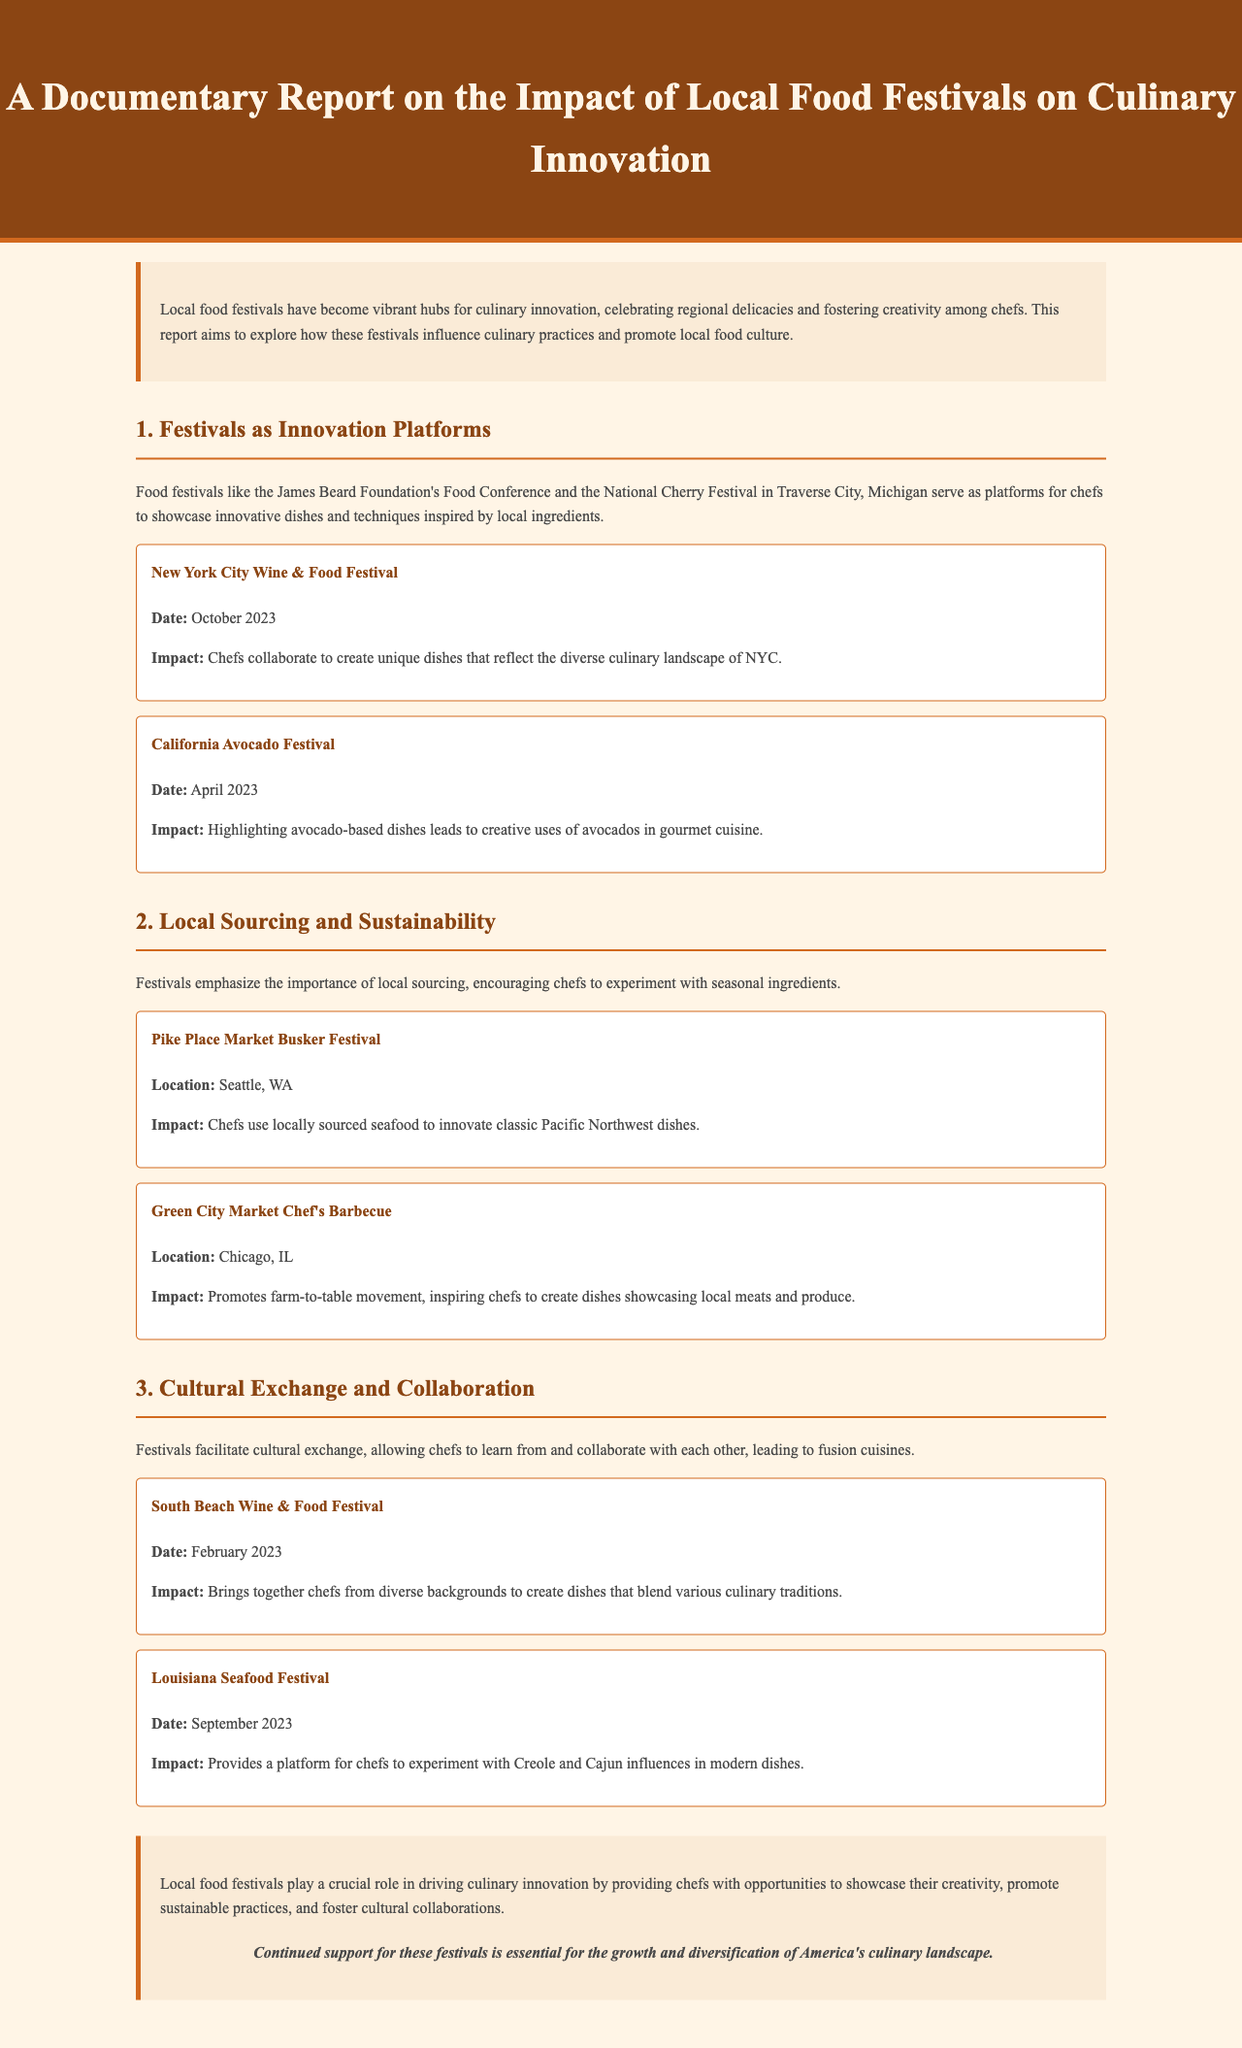What is the title of the report? The title of the report is clearly stated in the header section of the document.
Answer: A Documentary Report on the Impact of Local Food Festivals on Culinary Innovation What is the date of the New York City Wine & Food Festival? The date is mentioned in the example under the section about Festivals as Innovation Platforms.
Answer: October 2023 What local sourcing emphasis is highlighted in the report? The report discusses the promotion of local sourcing and seasonal ingredients throughout the section on Local Sourcing and Sustainability.
Answer: Local sourcing Which festival emphasizes the use of locally sourced seafood? The document specifies which festival focuses on seafood under the section about Local Sourcing and Sustainability.
Answer: Pike Place Market Busker Festival What impact does the South Beach Wine & Food Festival have? The impact is explained in the Cultural Exchange and Collaboration section, addressing the blending of culinary traditions.
Answer: Blends various culinary traditions What is the primary conclusion about local food festivals? The conclusion summarizes the overall impact of food festivals emphasized in the report.
Answer: Driving culinary innovation How many examples are provided under the section on Festivals as Innovation Platforms? The document lists the number of examples in that section for clarity.
Answer: Two In which city is the Green City Market Chef's Barbecue held? The location of this event is mentioned in the Local Sourcing and Sustainability section.
Answer: Chicago, IL 